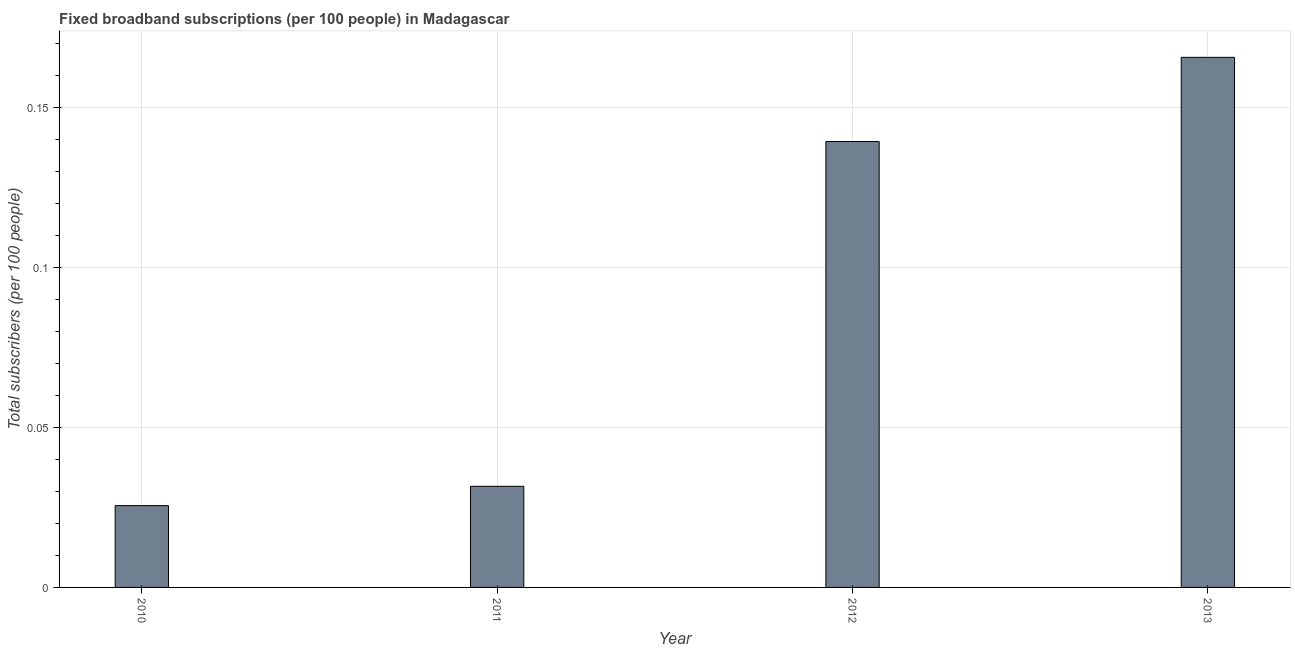Does the graph contain grids?
Keep it short and to the point. Yes. What is the title of the graph?
Give a very brief answer. Fixed broadband subscriptions (per 100 people) in Madagascar. What is the label or title of the Y-axis?
Offer a terse response. Total subscribers (per 100 people). What is the total number of fixed broadband subscriptions in 2010?
Ensure brevity in your answer.  0.03. Across all years, what is the maximum total number of fixed broadband subscriptions?
Ensure brevity in your answer.  0.17. Across all years, what is the minimum total number of fixed broadband subscriptions?
Your answer should be compact. 0.03. What is the sum of the total number of fixed broadband subscriptions?
Offer a terse response. 0.36. What is the difference between the total number of fixed broadband subscriptions in 2012 and 2013?
Provide a succinct answer. -0.03. What is the average total number of fixed broadband subscriptions per year?
Provide a succinct answer. 0.09. What is the median total number of fixed broadband subscriptions?
Give a very brief answer. 0.09. In how many years, is the total number of fixed broadband subscriptions greater than 0.11 ?
Provide a short and direct response. 2. What is the ratio of the total number of fixed broadband subscriptions in 2011 to that in 2013?
Give a very brief answer. 0.19. Is the difference between the total number of fixed broadband subscriptions in 2011 and 2013 greater than the difference between any two years?
Provide a succinct answer. No. What is the difference between the highest and the second highest total number of fixed broadband subscriptions?
Offer a terse response. 0.03. What is the difference between the highest and the lowest total number of fixed broadband subscriptions?
Your response must be concise. 0.14. How many bars are there?
Provide a succinct answer. 4. How many years are there in the graph?
Your response must be concise. 4. What is the Total subscribers (per 100 people) in 2010?
Provide a short and direct response. 0.03. What is the Total subscribers (per 100 people) of 2011?
Ensure brevity in your answer.  0.03. What is the Total subscribers (per 100 people) of 2012?
Your answer should be compact. 0.14. What is the Total subscribers (per 100 people) in 2013?
Give a very brief answer. 0.17. What is the difference between the Total subscribers (per 100 people) in 2010 and 2011?
Provide a short and direct response. -0.01. What is the difference between the Total subscribers (per 100 people) in 2010 and 2012?
Your answer should be compact. -0.11. What is the difference between the Total subscribers (per 100 people) in 2010 and 2013?
Provide a short and direct response. -0.14. What is the difference between the Total subscribers (per 100 people) in 2011 and 2012?
Ensure brevity in your answer.  -0.11. What is the difference between the Total subscribers (per 100 people) in 2011 and 2013?
Offer a terse response. -0.13. What is the difference between the Total subscribers (per 100 people) in 2012 and 2013?
Your response must be concise. -0.03. What is the ratio of the Total subscribers (per 100 people) in 2010 to that in 2011?
Offer a very short reply. 0.81. What is the ratio of the Total subscribers (per 100 people) in 2010 to that in 2012?
Offer a terse response. 0.18. What is the ratio of the Total subscribers (per 100 people) in 2010 to that in 2013?
Keep it short and to the point. 0.15. What is the ratio of the Total subscribers (per 100 people) in 2011 to that in 2012?
Make the answer very short. 0.23. What is the ratio of the Total subscribers (per 100 people) in 2011 to that in 2013?
Provide a succinct answer. 0.19. What is the ratio of the Total subscribers (per 100 people) in 2012 to that in 2013?
Offer a terse response. 0.84. 